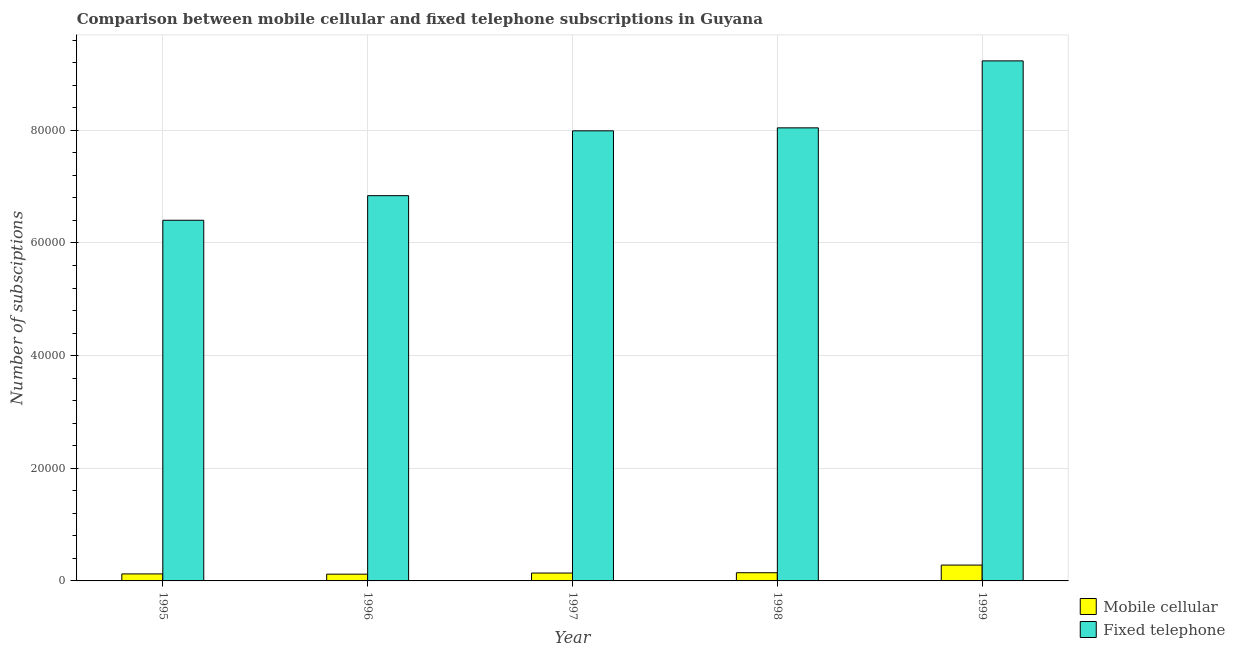How many different coloured bars are there?
Your answer should be compact. 2. How many groups of bars are there?
Provide a succinct answer. 5. Are the number of bars per tick equal to the number of legend labels?
Your response must be concise. Yes. How many bars are there on the 5th tick from the left?
Your answer should be compact. 2. What is the label of the 4th group of bars from the left?
Make the answer very short. 1998. What is the number of fixed telephone subscriptions in 1995?
Offer a very short reply. 6.40e+04. Across all years, what is the maximum number of mobile cellular subscriptions?
Make the answer very short. 2815. Across all years, what is the minimum number of fixed telephone subscriptions?
Your answer should be very brief. 6.40e+04. In which year was the number of fixed telephone subscriptions minimum?
Offer a very short reply. 1995. What is the total number of mobile cellular subscriptions in the graph?
Provide a short and direct response. 8112. What is the difference between the number of fixed telephone subscriptions in 1998 and that in 1999?
Ensure brevity in your answer.  -1.19e+04. What is the difference between the number of fixed telephone subscriptions in 1996 and the number of mobile cellular subscriptions in 1998?
Your response must be concise. -1.20e+04. What is the average number of mobile cellular subscriptions per year?
Your answer should be compact. 1622.4. In the year 1996, what is the difference between the number of fixed telephone subscriptions and number of mobile cellular subscriptions?
Ensure brevity in your answer.  0. What is the ratio of the number of mobile cellular subscriptions in 1995 to that in 1996?
Provide a succinct answer. 1.04. Is the difference between the number of fixed telephone subscriptions in 1995 and 1998 greater than the difference between the number of mobile cellular subscriptions in 1995 and 1998?
Ensure brevity in your answer.  No. What is the difference between the highest and the second highest number of mobile cellular subscriptions?
Offer a very short reply. 1361. What is the difference between the highest and the lowest number of fixed telephone subscriptions?
Provide a succinct answer. 2.83e+04. In how many years, is the number of fixed telephone subscriptions greater than the average number of fixed telephone subscriptions taken over all years?
Ensure brevity in your answer.  3. Is the sum of the number of fixed telephone subscriptions in 1997 and 1998 greater than the maximum number of mobile cellular subscriptions across all years?
Keep it short and to the point. Yes. What does the 2nd bar from the left in 1998 represents?
Your answer should be very brief. Fixed telephone. What does the 1st bar from the right in 1997 represents?
Provide a succinct answer. Fixed telephone. Are all the bars in the graph horizontal?
Your answer should be compact. No. How many years are there in the graph?
Make the answer very short. 5. Does the graph contain any zero values?
Provide a short and direct response. No. Where does the legend appear in the graph?
Give a very brief answer. Bottom right. How many legend labels are there?
Make the answer very short. 2. What is the title of the graph?
Offer a terse response. Comparison between mobile cellular and fixed telephone subscriptions in Guyana. Does "Forest" appear as one of the legend labels in the graph?
Your answer should be compact. No. What is the label or title of the X-axis?
Keep it short and to the point. Year. What is the label or title of the Y-axis?
Keep it short and to the point. Number of subsciptions. What is the Number of subsciptions in Mobile cellular in 1995?
Your answer should be very brief. 1243. What is the Number of subsciptions in Fixed telephone in 1995?
Offer a very short reply. 6.40e+04. What is the Number of subsciptions of Mobile cellular in 1996?
Your answer should be very brief. 1200. What is the Number of subsciptions in Fixed telephone in 1996?
Provide a succinct answer. 6.84e+04. What is the Number of subsciptions of Mobile cellular in 1997?
Give a very brief answer. 1400. What is the Number of subsciptions of Fixed telephone in 1997?
Your response must be concise. 7.99e+04. What is the Number of subsciptions in Mobile cellular in 1998?
Offer a terse response. 1454. What is the Number of subsciptions in Fixed telephone in 1998?
Your answer should be very brief. 8.04e+04. What is the Number of subsciptions in Mobile cellular in 1999?
Give a very brief answer. 2815. What is the Number of subsciptions in Fixed telephone in 1999?
Your response must be concise. 9.23e+04. Across all years, what is the maximum Number of subsciptions in Mobile cellular?
Offer a very short reply. 2815. Across all years, what is the maximum Number of subsciptions in Fixed telephone?
Provide a short and direct response. 9.23e+04. Across all years, what is the minimum Number of subsciptions of Mobile cellular?
Ensure brevity in your answer.  1200. Across all years, what is the minimum Number of subsciptions in Fixed telephone?
Provide a short and direct response. 6.40e+04. What is the total Number of subsciptions in Mobile cellular in the graph?
Keep it short and to the point. 8112. What is the total Number of subsciptions of Fixed telephone in the graph?
Your response must be concise. 3.85e+05. What is the difference between the Number of subsciptions of Mobile cellular in 1995 and that in 1996?
Ensure brevity in your answer.  43. What is the difference between the Number of subsciptions of Fixed telephone in 1995 and that in 1996?
Provide a short and direct response. -4366. What is the difference between the Number of subsciptions of Mobile cellular in 1995 and that in 1997?
Offer a terse response. -157. What is the difference between the Number of subsciptions of Fixed telephone in 1995 and that in 1997?
Your answer should be very brief. -1.59e+04. What is the difference between the Number of subsciptions in Mobile cellular in 1995 and that in 1998?
Ensure brevity in your answer.  -211. What is the difference between the Number of subsciptions of Fixed telephone in 1995 and that in 1998?
Offer a very short reply. -1.64e+04. What is the difference between the Number of subsciptions in Mobile cellular in 1995 and that in 1999?
Provide a short and direct response. -1572. What is the difference between the Number of subsciptions of Fixed telephone in 1995 and that in 1999?
Provide a succinct answer. -2.83e+04. What is the difference between the Number of subsciptions in Mobile cellular in 1996 and that in 1997?
Your answer should be compact. -200. What is the difference between the Number of subsciptions of Fixed telephone in 1996 and that in 1997?
Your response must be concise. -1.15e+04. What is the difference between the Number of subsciptions of Mobile cellular in 1996 and that in 1998?
Keep it short and to the point. -254. What is the difference between the Number of subsciptions in Fixed telephone in 1996 and that in 1998?
Provide a succinct answer. -1.20e+04. What is the difference between the Number of subsciptions in Mobile cellular in 1996 and that in 1999?
Offer a very short reply. -1615. What is the difference between the Number of subsciptions of Fixed telephone in 1996 and that in 1999?
Provide a succinct answer. -2.39e+04. What is the difference between the Number of subsciptions of Mobile cellular in 1997 and that in 1998?
Make the answer very short. -54. What is the difference between the Number of subsciptions of Fixed telephone in 1997 and that in 1998?
Your response must be concise. -528. What is the difference between the Number of subsciptions in Mobile cellular in 1997 and that in 1999?
Give a very brief answer. -1415. What is the difference between the Number of subsciptions of Fixed telephone in 1997 and that in 1999?
Offer a very short reply. -1.24e+04. What is the difference between the Number of subsciptions of Mobile cellular in 1998 and that in 1999?
Provide a succinct answer. -1361. What is the difference between the Number of subsciptions of Fixed telephone in 1998 and that in 1999?
Provide a short and direct response. -1.19e+04. What is the difference between the Number of subsciptions of Mobile cellular in 1995 and the Number of subsciptions of Fixed telephone in 1996?
Provide a succinct answer. -6.72e+04. What is the difference between the Number of subsciptions in Mobile cellular in 1995 and the Number of subsciptions in Fixed telephone in 1997?
Your answer should be very brief. -7.87e+04. What is the difference between the Number of subsciptions of Mobile cellular in 1995 and the Number of subsciptions of Fixed telephone in 1998?
Make the answer very short. -7.92e+04. What is the difference between the Number of subsciptions in Mobile cellular in 1995 and the Number of subsciptions in Fixed telephone in 1999?
Your answer should be very brief. -9.11e+04. What is the difference between the Number of subsciptions of Mobile cellular in 1996 and the Number of subsciptions of Fixed telephone in 1997?
Your response must be concise. -7.87e+04. What is the difference between the Number of subsciptions of Mobile cellular in 1996 and the Number of subsciptions of Fixed telephone in 1998?
Make the answer very short. -7.92e+04. What is the difference between the Number of subsciptions in Mobile cellular in 1996 and the Number of subsciptions in Fixed telephone in 1999?
Make the answer very short. -9.11e+04. What is the difference between the Number of subsciptions in Mobile cellular in 1997 and the Number of subsciptions in Fixed telephone in 1998?
Your response must be concise. -7.90e+04. What is the difference between the Number of subsciptions in Mobile cellular in 1997 and the Number of subsciptions in Fixed telephone in 1999?
Your answer should be compact. -9.09e+04. What is the difference between the Number of subsciptions of Mobile cellular in 1998 and the Number of subsciptions of Fixed telephone in 1999?
Your answer should be compact. -9.09e+04. What is the average Number of subsciptions in Mobile cellular per year?
Your response must be concise. 1622.4. What is the average Number of subsciptions in Fixed telephone per year?
Your answer should be compact. 7.70e+04. In the year 1995, what is the difference between the Number of subsciptions of Mobile cellular and Number of subsciptions of Fixed telephone?
Ensure brevity in your answer.  -6.28e+04. In the year 1996, what is the difference between the Number of subsciptions of Mobile cellular and Number of subsciptions of Fixed telephone?
Keep it short and to the point. -6.72e+04. In the year 1997, what is the difference between the Number of subsciptions of Mobile cellular and Number of subsciptions of Fixed telephone?
Provide a succinct answer. -7.85e+04. In the year 1998, what is the difference between the Number of subsciptions in Mobile cellular and Number of subsciptions in Fixed telephone?
Your answer should be very brief. -7.90e+04. In the year 1999, what is the difference between the Number of subsciptions in Mobile cellular and Number of subsciptions in Fixed telephone?
Give a very brief answer. -8.95e+04. What is the ratio of the Number of subsciptions of Mobile cellular in 1995 to that in 1996?
Your answer should be very brief. 1.04. What is the ratio of the Number of subsciptions in Fixed telephone in 1995 to that in 1996?
Your answer should be compact. 0.94. What is the ratio of the Number of subsciptions in Mobile cellular in 1995 to that in 1997?
Your response must be concise. 0.89. What is the ratio of the Number of subsciptions of Fixed telephone in 1995 to that in 1997?
Keep it short and to the point. 0.8. What is the ratio of the Number of subsciptions of Mobile cellular in 1995 to that in 1998?
Offer a very short reply. 0.85. What is the ratio of the Number of subsciptions in Fixed telephone in 1995 to that in 1998?
Make the answer very short. 0.8. What is the ratio of the Number of subsciptions of Mobile cellular in 1995 to that in 1999?
Make the answer very short. 0.44. What is the ratio of the Number of subsciptions of Fixed telephone in 1995 to that in 1999?
Provide a short and direct response. 0.69. What is the ratio of the Number of subsciptions in Fixed telephone in 1996 to that in 1997?
Provide a short and direct response. 0.86. What is the ratio of the Number of subsciptions of Mobile cellular in 1996 to that in 1998?
Make the answer very short. 0.83. What is the ratio of the Number of subsciptions in Fixed telephone in 1996 to that in 1998?
Provide a short and direct response. 0.85. What is the ratio of the Number of subsciptions in Mobile cellular in 1996 to that in 1999?
Give a very brief answer. 0.43. What is the ratio of the Number of subsciptions of Fixed telephone in 1996 to that in 1999?
Your answer should be compact. 0.74. What is the ratio of the Number of subsciptions in Mobile cellular in 1997 to that in 1998?
Your answer should be very brief. 0.96. What is the ratio of the Number of subsciptions of Mobile cellular in 1997 to that in 1999?
Give a very brief answer. 0.5. What is the ratio of the Number of subsciptions of Fixed telephone in 1997 to that in 1999?
Ensure brevity in your answer.  0.87. What is the ratio of the Number of subsciptions in Mobile cellular in 1998 to that in 1999?
Give a very brief answer. 0.52. What is the ratio of the Number of subsciptions of Fixed telephone in 1998 to that in 1999?
Keep it short and to the point. 0.87. What is the difference between the highest and the second highest Number of subsciptions of Mobile cellular?
Provide a succinct answer. 1361. What is the difference between the highest and the second highest Number of subsciptions of Fixed telephone?
Your response must be concise. 1.19e+04. What is the difference between the highest and the lowest Number of subsciptions in Mobile cellular?
Ensure brevity in your answer.  1615. What is the difference between the highest and the lowest Number of subsciptions in Fixed telephone?
Provide a succinct answer. 2.83e+04. 